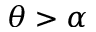<formula> <loc_0><loc_0><loc_500><loc_500>\theta > \alpha</formula> 